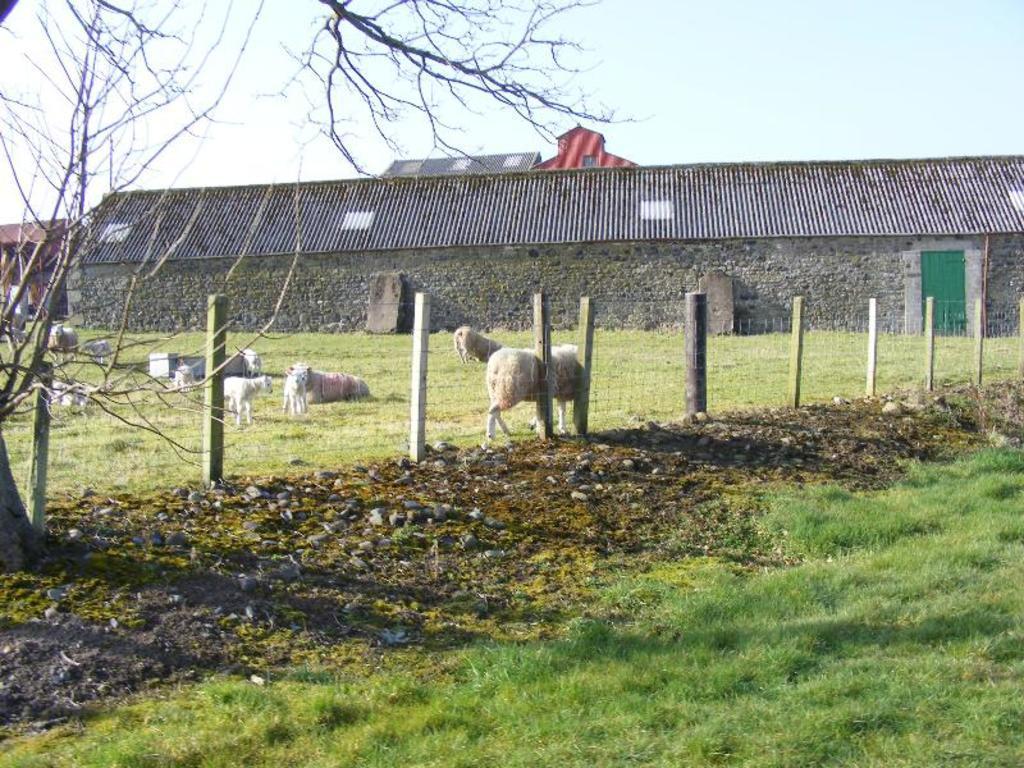Describe this image in one or two sentences. In this image there are sheep standing on the ground. In front of them there is a fencing. Behind them there is a house. At the top there is the sky. To the left there is a tree. At the bottom there are stones and grass on the ground. 